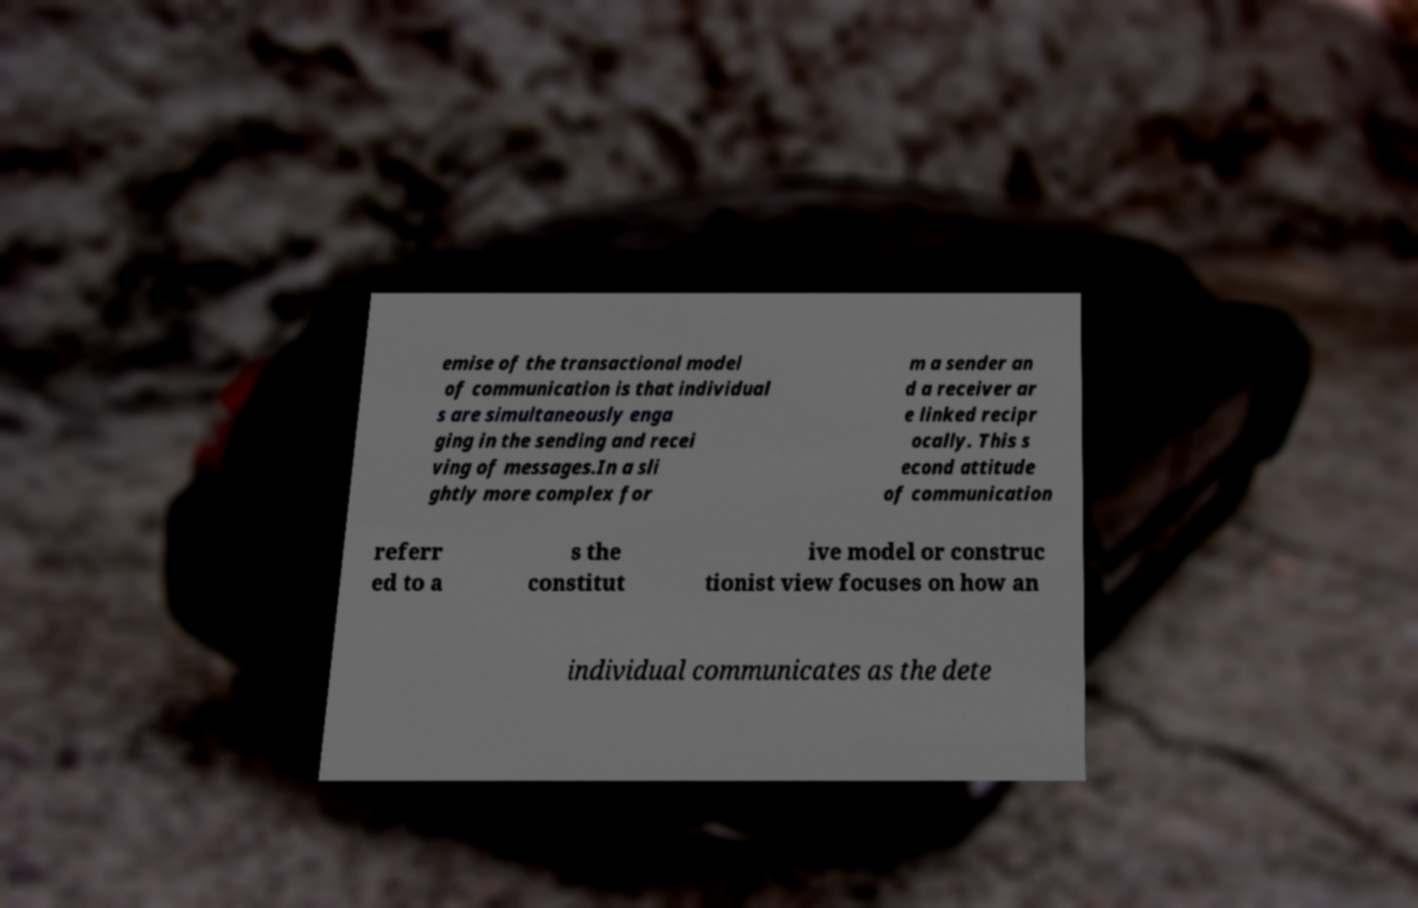Can you accurately transcribe the text from the provided image for me? emise of the transactional model of communication is that individual s are simultaneously enga ging in the sending and recei ving of messages.In a sli ghtly more complex for m a sender an d a receiver ar e linked recipr ocally. This s econd attitude of communication referr ed to a s the constitut ive model or construc tionist view focuses on how an individual communicates as the dete 